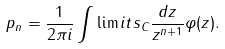<formula> <loc_0><loc_0><loc_500><loc_500>p _ { n } = \frac { 1 } { 2 \pi i } \int \lim i t s _ { C } \frac { d z } { z ^ { n + 1 } } \varphi ( z ) .</formula> 